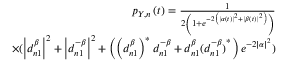<formula> <loc_0><loc_0><loc_500><loc_500>\begin{array} { r } { p _ { Y , n } \left ( t \right ) = \frac { 1 } { 2 \left ( 1 + e ^ { - 2 \left ( \left | \alpha \left ( t \right ) \right | ^ { 2 } + \left | \beta \left ( t \right ) \right | ^ { 2 } \right ) } \right ) } } \\ { \times ( \left | d _ { n 1 } ^ { \beta } \right | ^ { 2 } + \left | d _ { n 1 } ^ { - \beta } \right | ^ { 2 } + \left ( \left ( d _ { n 1 } ^ { \beta } \right ) ^ { \ast } d _ { n 1 } ^ { - \beta } + d _ { n 1 } ^ { \beta } { ( d _ { n 1 } ^ { - \beta } ) } ^ { \ast } \right ) e ^ { - 2 \left | \alpha \right | ^ { 2 } } ) } \end{array}</formula> 